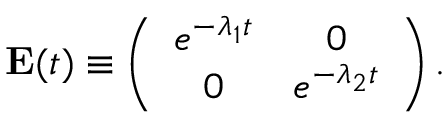<formula> <loc_0><loc_0><loc_500><loc_500>\begin{array} { r } { { E } ( t ) \equiv \left ( \begin{array} { c c } { e ^ { - \lambda _ { 1 } t } } & { 0 } \\ { 0 } & { e ^ { - \lambda _ { 2 } t } } \end{array} \right ) . } \end{array}</formula> 